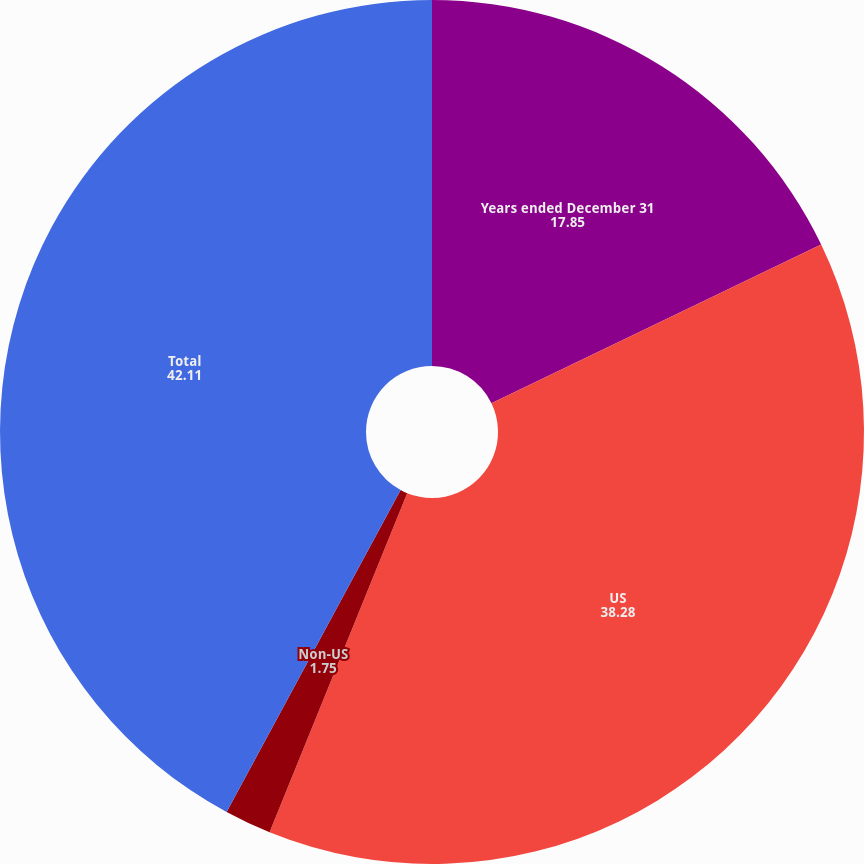<chart> <loc_0><loc_0><loc_500><loc_500><pie_chart><fcel>Years ended December 31<fcel>US<fcel>Non-US<fcel>Total<nl><fcel>17.85%<fcel>38.28%<fcel>1.75%<fcel>42.11%<nl></chart> 